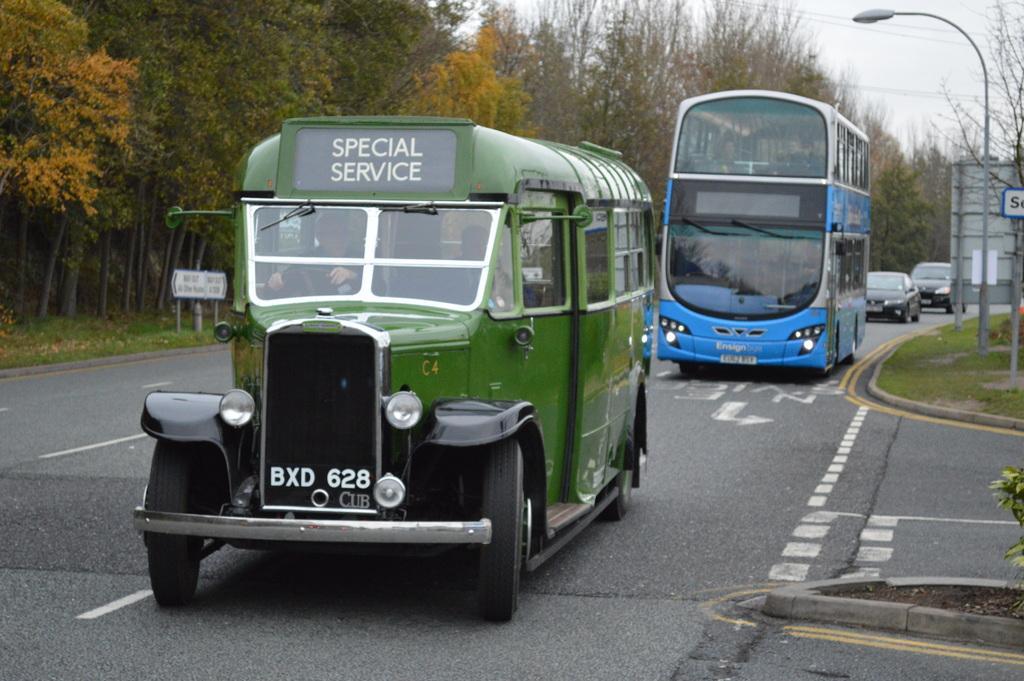In one or two sentences, can you explain what this image depicts? This picture shows a mini and a double-decker bus and couple of cars on the road and we see trees and a hoarding board to the pole and we see a pole light on the sidewalk. 